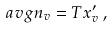Convert formula to latex. <formula><loc_0><loc_0><loc_500><loc_500>\ a v g { n _ { v } } = T x _ { v } ^ { \prime } \, ,</formula> 